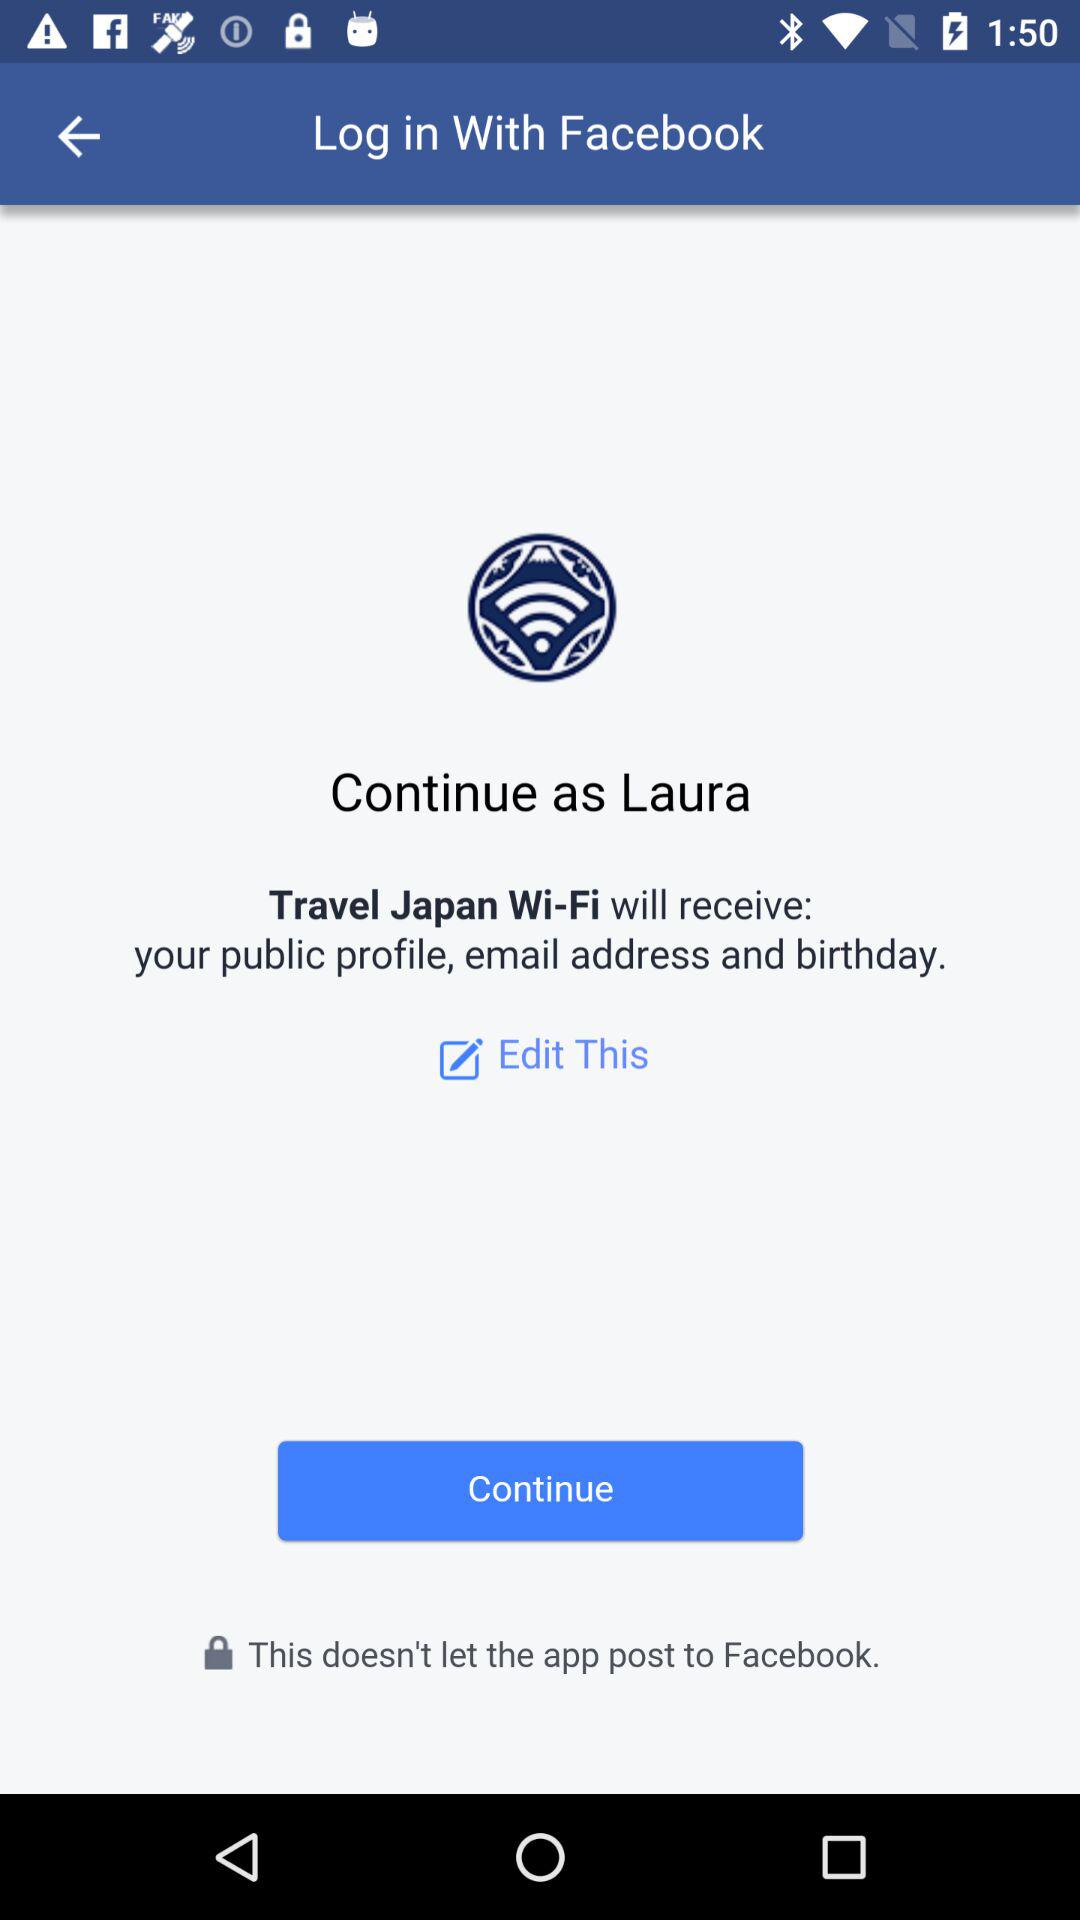What application is asking for permission? The application asking for permission is "Travel Japan Wi-Fi". 